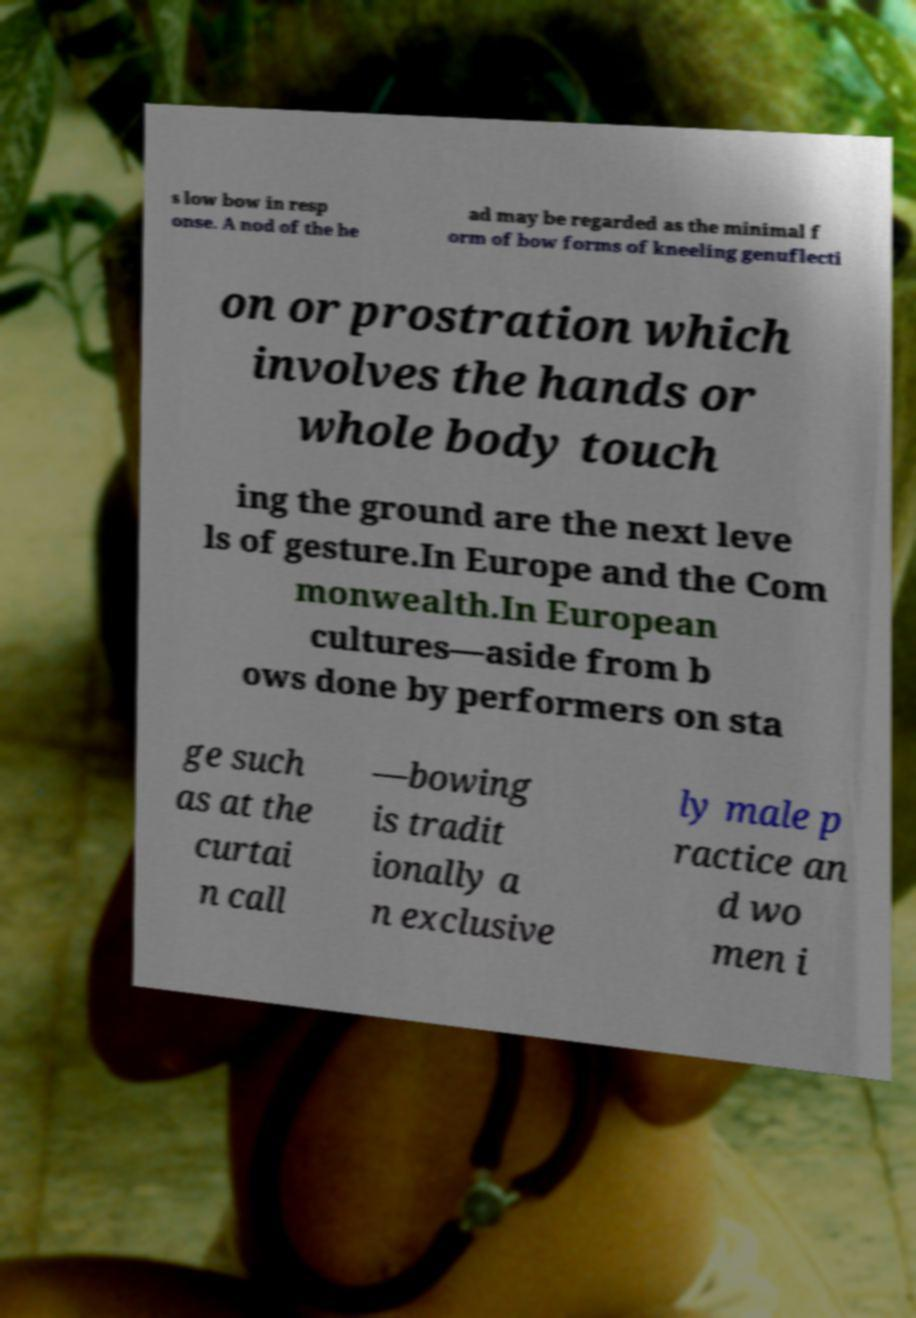Please identify and transcribe the text found in this image. s low bow in resp onse. A nod of the he ad may be regarded as the minimal f orm of bow forms of kneeling genuflecti on or prostration which involves the hands or whole body touch ing the ground are the next leve ls of gesture.In Europe and the Com monwealth.In European cultures—aside from b ows done by performers on sta ge such as at the curtai n call —bowing is tradit ionally a n exclusive ly male p ractice an d wo men i 